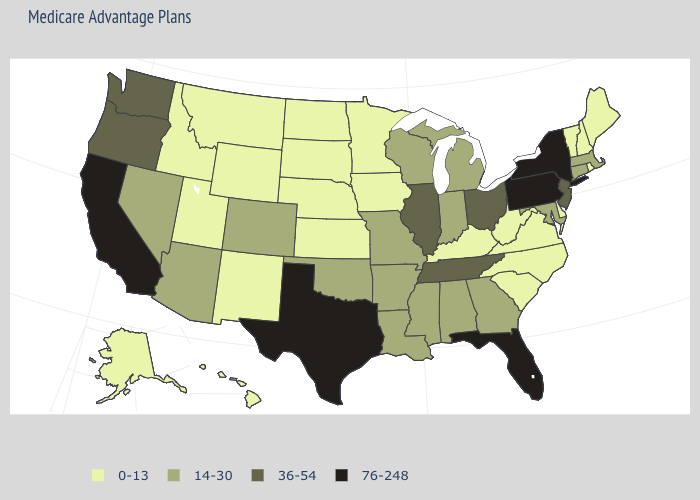What is the lowest value in the MidWest?
Concise answer only. 0-13. What is the value of Mississippi?
Give a very brief answer. 14-30. Among the states that border Arkansas , does Texas have the highest value?
Keep it brief. Yes. What is the highest value in the West ?
Quick response, please. 76-248. What is the highest value in the Northeast ?
Concise answer only. 76-248. What is the value of South Carolina?
Short answer required. 0-13. Does Colorado have the lowest value in the USA?
Quick response, please. No. Which states hav the highest value in the MidWest?
Be succinct. Illinois, Ohio. Does the first symbol in the legend represent the smallest category?
Answer briefly. Yes. What is the highest value in states that border North Carolina?
Answer briefly. 36-54. What is the value of Pennsylvania?
Concise answer only. 76-248. What is the lowest value in the USA?
Short answer required. 0-13. Does New Jersey have a lower value than Illinois?
Give a very brief answer. No. Among the states that border Rhode Island , which have the highest value?
Keep it brief. Connecticut, Massachusetts. 